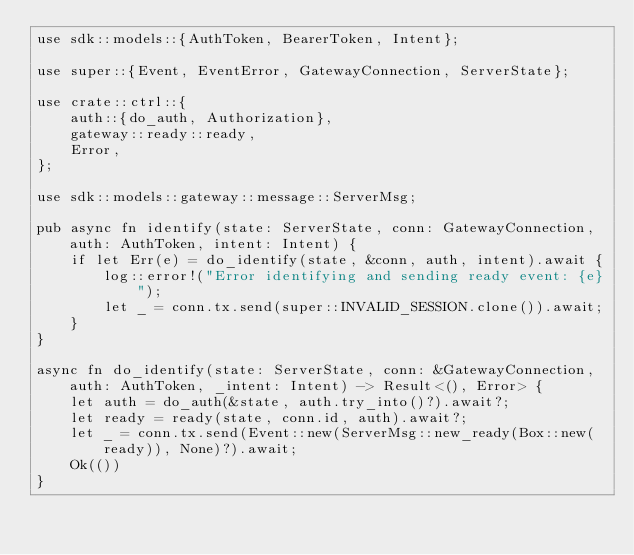Convert code to text. <code><loc_0><loc_0><loc_500><loc_500><_Rust_>use sdk::models::{AuthToken, BearerToken, Intent};

use super::{Event, EventError, GatewayConnection, ServerState};

use crate::ctrl::{
    auth::{do_auth, Authorization},
    gateway::ready::ready,
    Error,
};

use sdk::models::gateway::message::ServerMsg;

pub async fn identify(state: ServerState, conn: GatewayConnection, auth: AuthToken, intent: Intent) {
    if let Err(e) = do_identify(state, &conn, auth, intent).await {
        log::error!("Error identifying and sending ready event: {e}");
        let _ = conn.tx.send(super::INVALID_SESSION.clone()).await;
    }
}

async fn do_identify(state: ServerState, conn: &GatewayConnection, auth: AuthToken, _intent: Intent) -> Result<(), Error> {
    let auth = do_auth(&state, auth.try_into()?).await?;
    let ready = ready(state, conn.id, auth).await?;
    let _ = conn.tx.send(Event::new(ServerMsg::new_ready(Box::new(ready)), None)?).await;
    Ok(())
}
</code> 